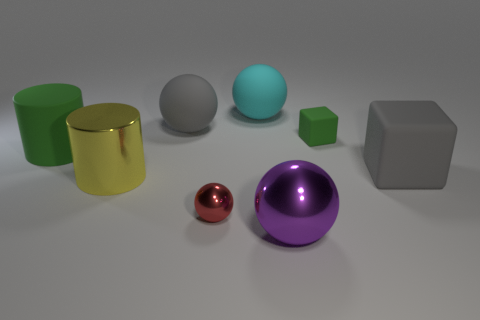Is there any other thing that has the same color as the big shiny cylinder?
Your response must be concise. No. Is the shape of the gray matte thing that is right of the green cube the same as  the yellow metal thing?
Keep it short and to the point. No. Are there fewer red shiny balls to the right of the small ball than cubes to the right of the small cube?
Offer a very short reply. Yes. What is the material of the large yellow object?
Your response must be concise. Metal. There is a big cube; is its color the same as the large rubber ball left of the small red metallic object?
Offer a very short reply. Yes. What number of large cyan matte balls are in front of the purple shiny thing?
Offer a very short reply. 0. Is the number of cyan things that are to the left of the large green rubber cylinder less than the number of large purple balls?
Keep it short and to the point. Yes. What color is the large rubber cube?
Provide a short and direct response. Gray. There is a shiny cylinder on the left side of the red metallic ball; is its color the same as the tiny metallic ball?
Your answer should be compact. No. What is the color of the other big object that is the same shape as the large yellow thing?
Ensure brevity in your answer.  Green. 